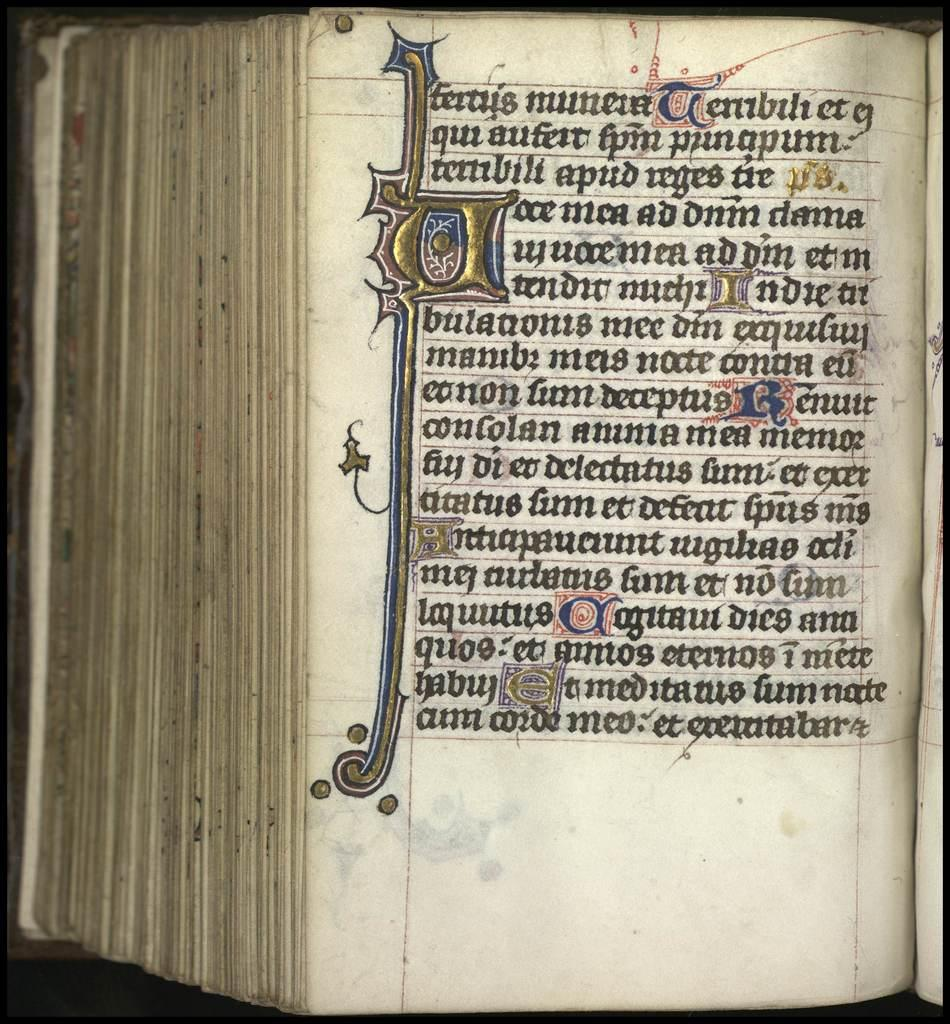<image>
Share a concise interpretation of the image provided. The old book shown is written in some other language than English 